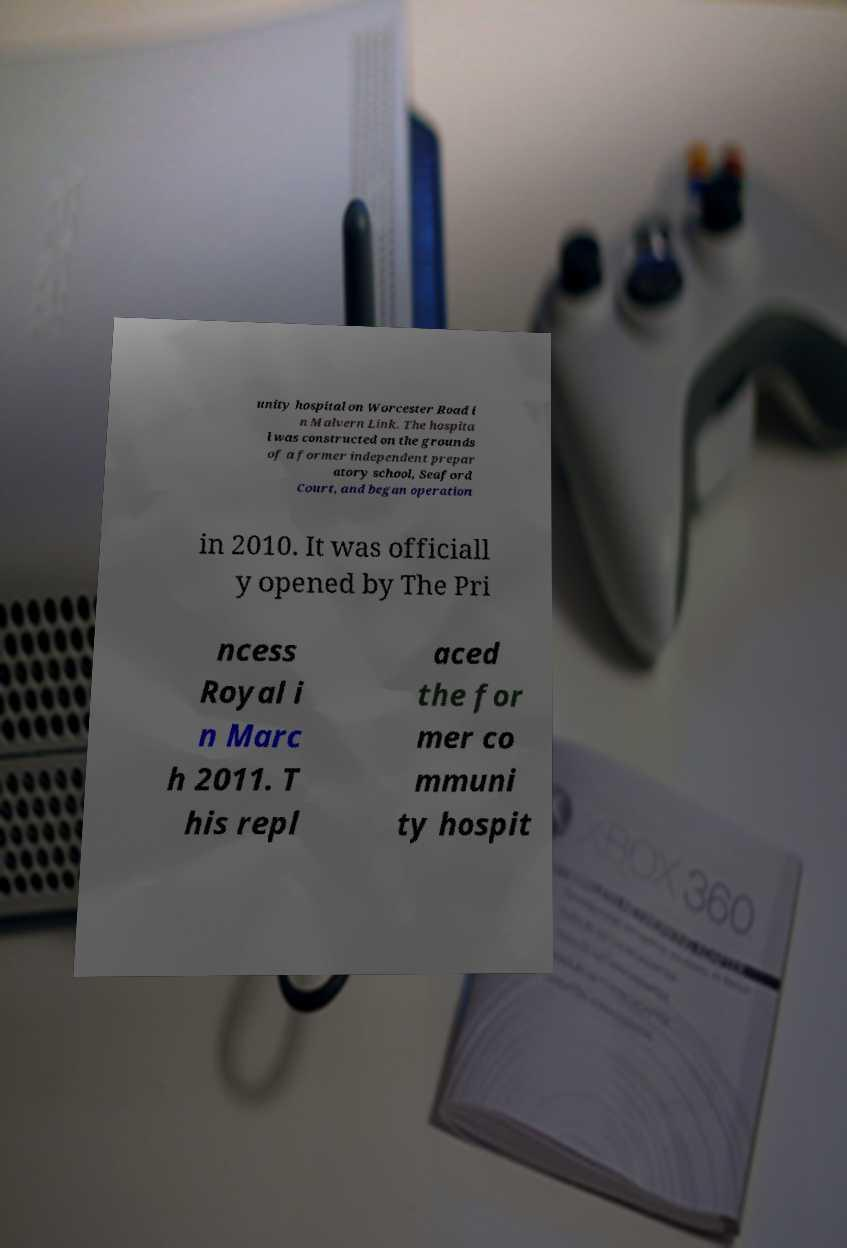Could you extract and type out the text from this image? unity hospital on Worcester Road i n Malvern Link. The hospita l was constructed on the grounds of a former independent prepar atory school, Seaford Court, and began operation in 2010. It was officiall y opened by The Pri ncess Royal i n Marc h 2011. T his repl aced the for mer co mmuni ty hospit 